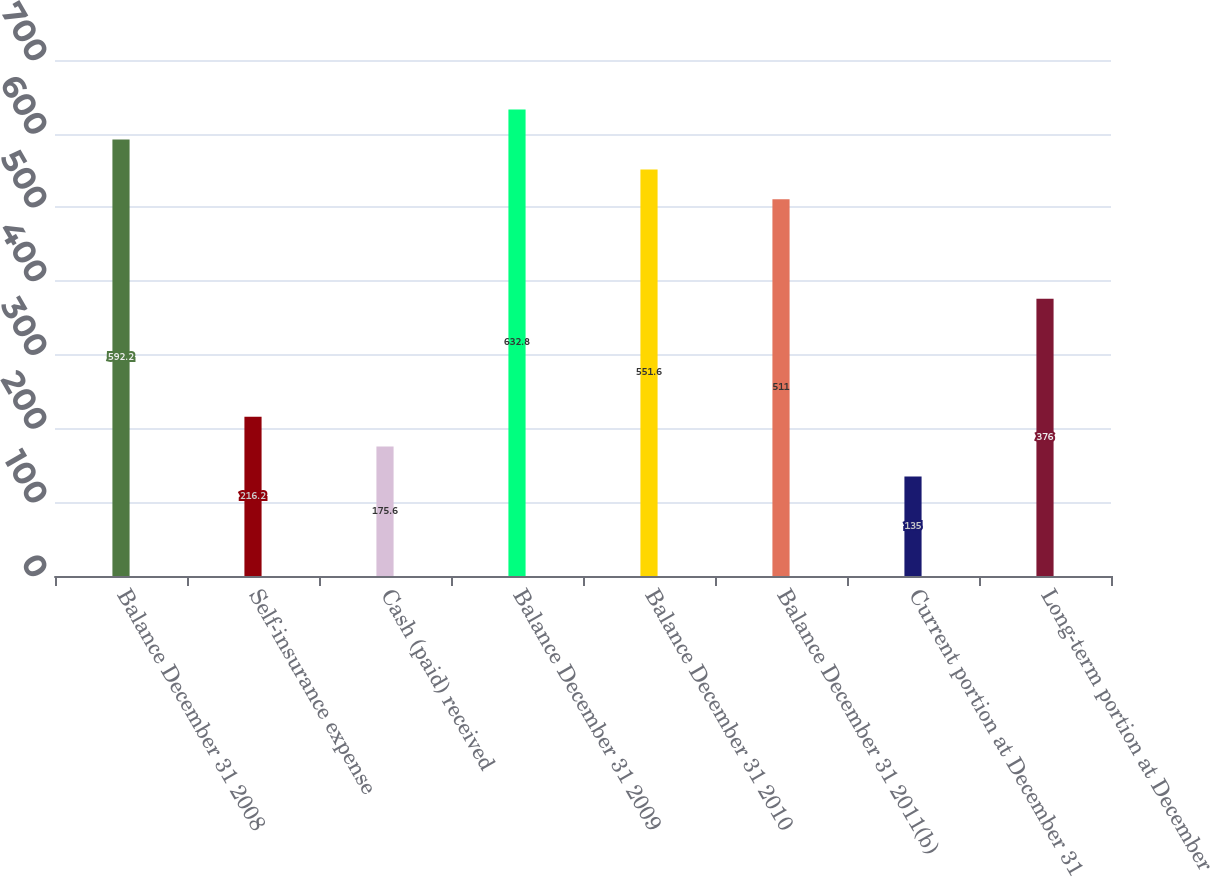<chart> <loc_0><loc_0><loc_500><loc_500><bar_chart><fcel>Balance December 31 2008<fcel>Self-insurance expense<fcel>Cash (paid) received<fcel>Balance December 31 2009<fcel>Balance December 31 2010<fcel>Balance December 31 2011(b)<fcel>Current portion at December 31<fcel>Long-term portion at December<nl><fcel>592.2<fcel>216.2<fcel>175.6<fcel>632.8<fcel>551.6<fcel>511<fcel>135<fcel>376<nl></chart> 